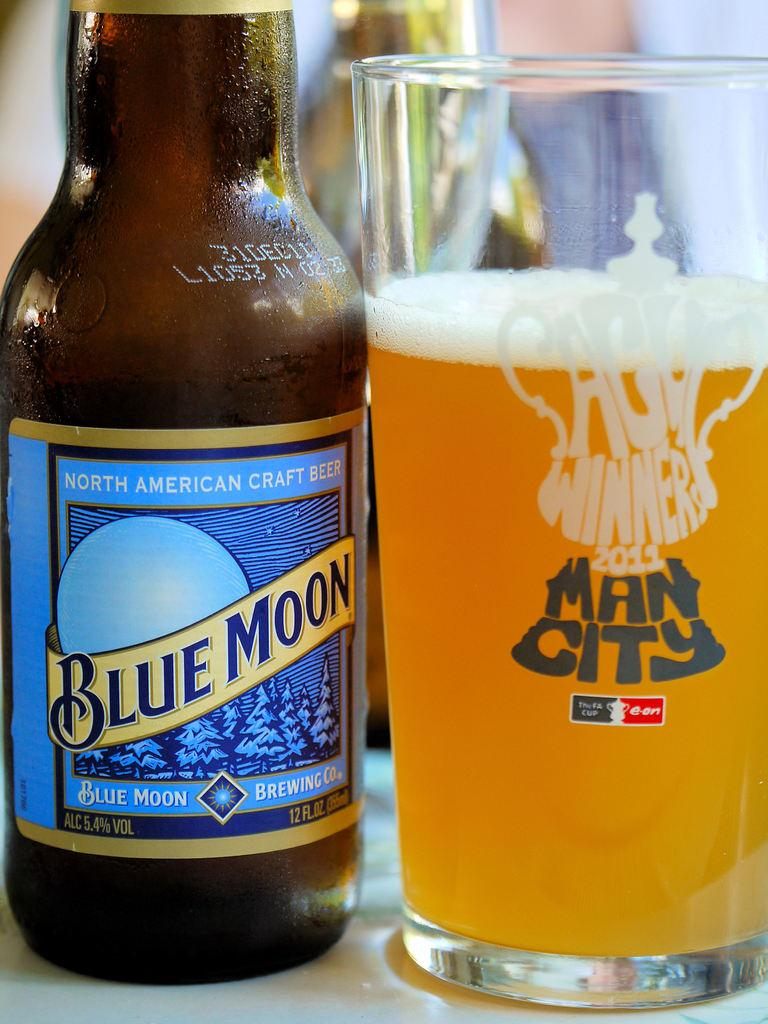<image>
Share a concise interpretation of the image provided. Bottle of blue moon north american craft beer with a man city glass beside it 